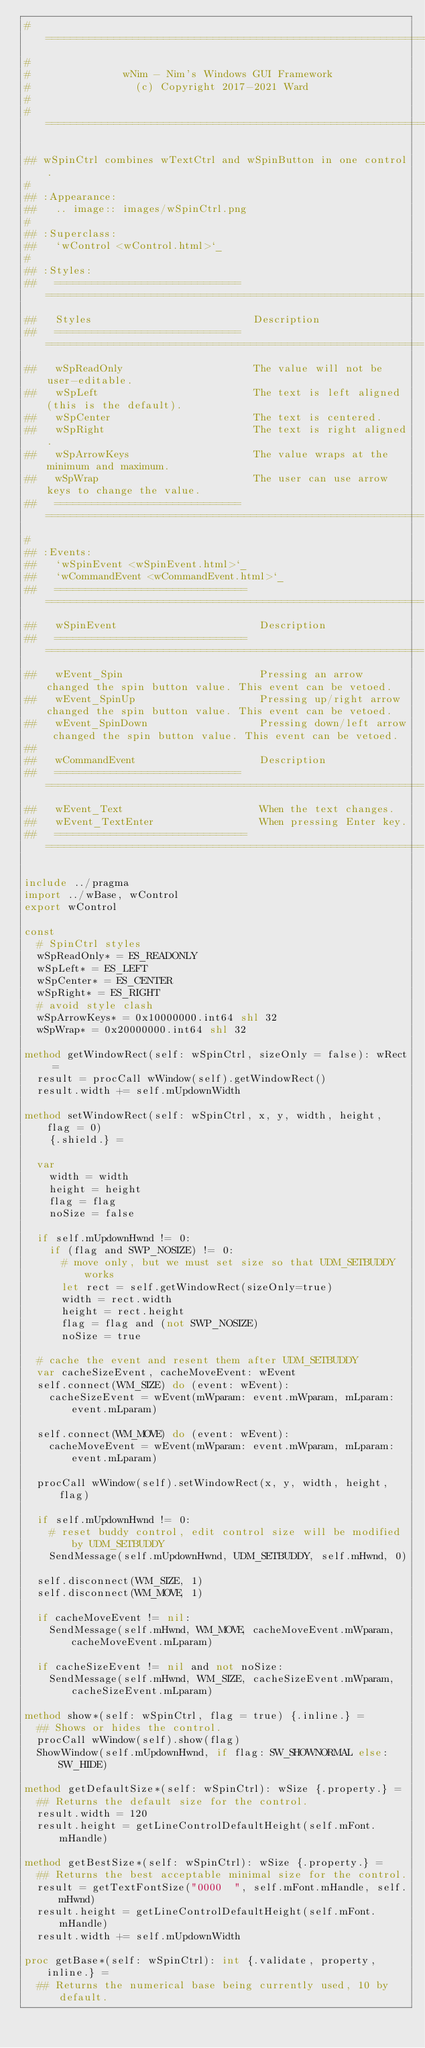<code> <loc_0><loc_0><loc_500><loc_500><_Nim_>#====================================================================
#
#               wNim - Nim's Windows GUI Framework
#                 (c) Copyright 2017-2021 Ward
#
#====================================================================

## wSpinCtrl combines wTextCtrl and wSpinButton in one control.
#
## :Appearance:
##   .. image:: images/wSpinCtrl.png
#
## :Superclass:
##   `wControl <wControl.html>`_
#
## :Styles:
##   ==============================  =============================================================
##   Styles                          Description
##   ==============================  =============================================================
##   wSpReadOnly                     The value will not be user-editable.
##   wSpLeft                         The text is left aligned (this is the default).
##   wSpCenter                       The text is centered.
##   wSpRight                        The text is right aligned.
##   wSpArrowKeys                    The value wraps at the minimum and maximum.
##   wSpWrap                         The user can use arrow keys to change the value.
##   ==============================  =============================================================
#
## :Events:
##   `wSpinEvent <wSpinEvent.html>`_
##   `wCommandEvent <wCommandEvent.html>`_
##   ===============================  =============================================================
##   wSpinEvent                       Description
##   ===============================  =============================================================
##   wEvent_Spin                      Pressing an arrow changed the spin button value. This event can be vetoed.
##   wEvent_SpinUp                    Pressing up/right arrow changed the spin button value. This event can be vetoed.
##   wEvent_SpinDown                  Pressing down/left arrow changed the spin button value. This event can be vetoed.
##
##   wCommandEvent                    Description
##   ==============================   =============================================================
##   wEvent_Text                      When the text changes.
##   wEvent_TextEnter                 When pressing Enter key.
##   ===============================  =============================================================

include ../pragma
import ../wBase, wControl
export wControl

const
  # SpinCtrl styles
  wSpReadOnly* = ES_READONLY
  wSpLeft* = ES_LEFT
  wSpCenter* = ES_CENTER
  wSpRight* = ES_RIGHT
  # avoid style clash
  wSpArrowKeys* = 0x10000000.int64 shl 32
  wSpWrap* = 0x20000000.int64 shl 32

method getWindowRect(self: wSpinCtrl, sizeOnly = false): wRect =
  result = procCall wWindow(self).getWindowRect()
  result.width += self.mUpdownWidth

method setWindowRect(self: wSpinCtrl, x, y, width, height, flag = 0)
    {.shield.} =

  var
    width = width
    height = height
    flag = flag
    noSize = false

  if self.mUpdownHwnd != 0:
    if (flag and SWP_NOSIZE) != 0:
      # move only, but we must set size so that UDM_SETBUDDY works
      let rect = self.getWindowRect(sizeOnly=true)
      width = rect.width
      height = rect.height
      flag = flag and (not SWP_NOSIZE)
      noSize = true

  # cache the event and resent them after UDM_SETBUDDY
  var cacheSizeEvent, cacheMoveEvent: wEvent
  self.connect(WM_SIZE) do (event: wEvent):
    cacheSizeEvent = wEvent(mWparam: event.mWparam, mLparam: event.mLparam)

  self.connect(WM_MOVE) do (event: wEvent):
    cacheMoveEvent = wEvent(mWparam: event.mWparam, mLparam: event.mLparam)

  procCall wWindow(self).setWindowRect(x, y, width, height, flag)

  if self.mUpdownHwnd != 0:
    # reset buddy control, edit control size will be modified by UDM_SETBUDDY
    SendMessage(self.mUpdownHwnd, UDM_SETBUDDY, self.mHwnd, 0)

  self.disconnect(WM_SIZE, 1)
  self.disconnect(WM_MOVE, 1)

  if cacheMoveEvent != nil:
    SendMessage(self.mHwnd, WM_MOVE, cacheMoveEvent.mWparam, cacheMoveEvent.mLparam)

  if cacheSizeEvent != nil and not noSize:
    SendMessage(self.mHwnd, WM_SIZE, cacheSizeEvent.mWparam, cacheSizeEvent.mLparam)

method show*(self: wSpinCtrl, flag = true) {.inline.} =
  ## Shows or hides the control.
  procCall wWindow(self).show(flag)
  ShowWindow(self.mUpdownHwnd, if flag: SW_SHOWNORMAL else: SW_HIDE)

method getDefaultSize*(self: wSpinCtrl): wSize {.property.} =
  ## Returns the default size for the control.
  result.width = 120
  result.height = getLineControlDefaultHeight(self.mFont.mHandle)

method getBestSize*(self: wSpinCtrl): wSize {.property.} =
  ## Returns the best acceptable minimal size for the control.
  result = getTextFontSize("0000  ", self.mFont.mHandle, self.mHwnd)
  result.height = getLineControlDefaultHeight(self.mFont.mHandle)
  result.width += self.mUpdownWidth

proc getBase*(self: wSpinCtrl): int {.validate, property, inline.} =
  ## Returns the numerical base being currently used, 10 by default.</code> 